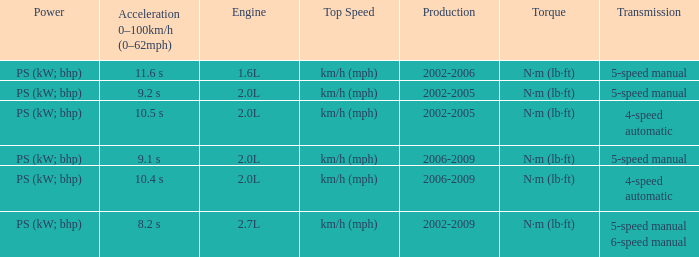What is the top speed of a 4-speed automatic with production in 2002-2005? Km/h (mph). 